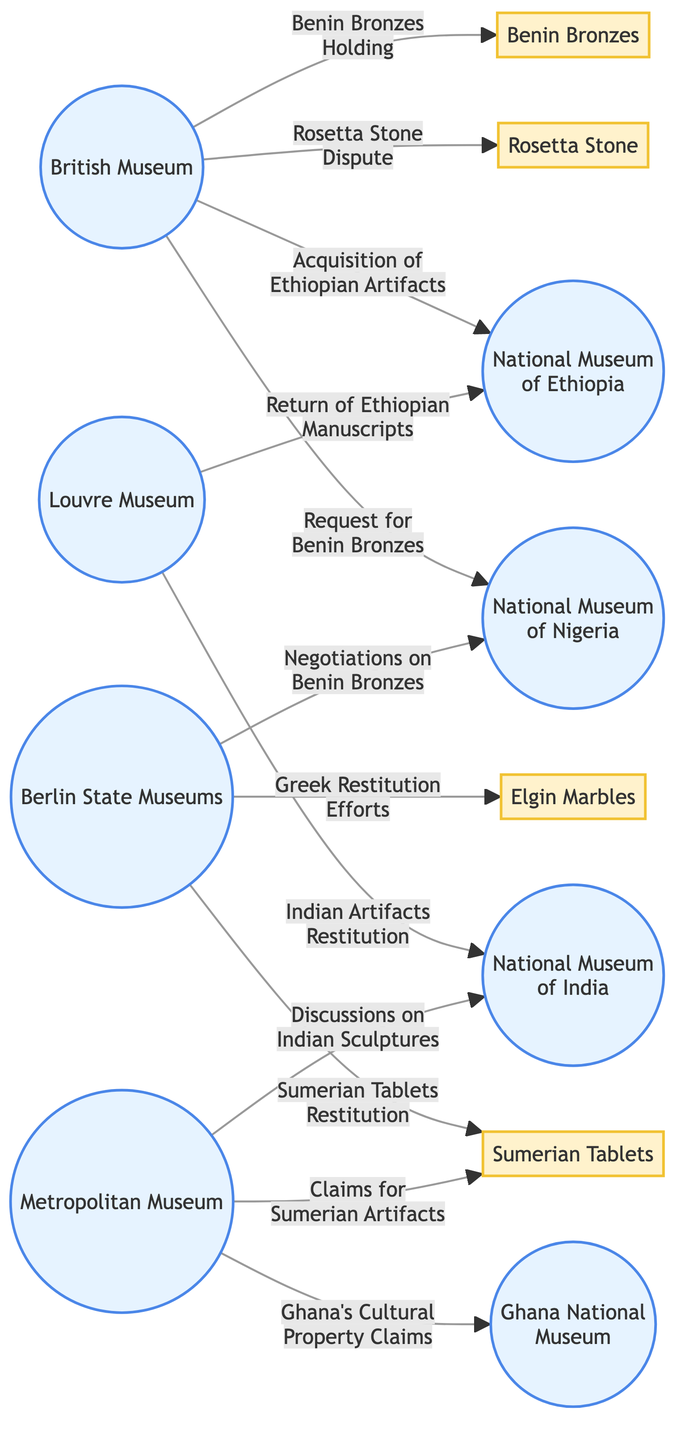What is the total number of nodes in the diagram? There are 12 nodes represented in the diagram, including both museums and artifacts. Each node corresponds to either a museum or a specific cultural artifact, which can be counted by looking at the list of nodes provided.
Answer: 12 Which museum is requesting the Benin Bronzes? The diagram indicates a directed edge from "The British Museum" to "National Museum of Nigeria" labeled "Request for Benin Bronzes." This shows that the British Museum has made a request to the National Museum of Nigeria regarding the Benin Bronzes.
Answer: The British Museum What artifact is linked to the Louvre Museum? The Louvre Museum has two connections in the diagram: one is with the "National Museum of Ethiopia" related to the return of manuscripts and another is with the "National Museum of India" concerning artifact restitution. By identifying these edges, we can see that both Ethiopian and Indian artifacts are involved.
Answer: Return of Ethiopian Manuscripts & Indian Artifacts Restitution How many museums are connected to the National Museum of Ethiopia? The National Museum of Ethiopia is connected to two museums: The British Museum and the Louvre Museum, as indicated by the edges stemming from these museums towards the Ethiopian museum.
Answer: 2 Which artifacts are associated with the Berlin State Museums? The Berlin State Museums is linked to two artifacts: the Benin Bronzes and the Sumerian Tablets, as seen from the edges that show negotiations and restitution efforts involving these items.
Answer: Benin Bronzes & Sumerian Tablets What is the relationship between the Metropolitan Museum of Art and the Ghana National Museum? The Metropolitan Museum of Art is connected to the Ghana National Museum through the edge labeled "Ghana's Cultural Property Claims." This relationship indicates a claim made by Ghana regarding its cultural property, which involves discussions or negotiations with the Metropolitan Museum.
Answer: Ghana's Cultural Property Claims What evidence is there for disputes regarding the Rosetta Stone? The diagram includes an edge labeled "Rosetta Stone Dispute" originating from the British Museum and pointing to the Rosetta Stone itself. This edge indicates an existing dispute over the ownership or handling of the Rosetta Stone.
Answer: Rosetta Stone Dispute Which country is seeking restitution for artifacts from the National Museum of India? The edges leading from the Louvre Museum and the Metropolitan Museum of Art both show connections involving Indian artifacts, specifically labeled "Indian Artifacts Restitution" and "Discussions on Indian Sculptures," respectively, indicating that both are involved in restitution efforts for artifacts from India.
Answer: India How many edges connect the Berlin State Museums to artifacts? The Berlin State Museums is connected by two edges that explicitly mention restitution or negotiations for artifacts (the Benin Bronzes and Sumerian Tablets). By counting these connections in the diagram, we can sum to arrive at the total number.
Answer: 2 